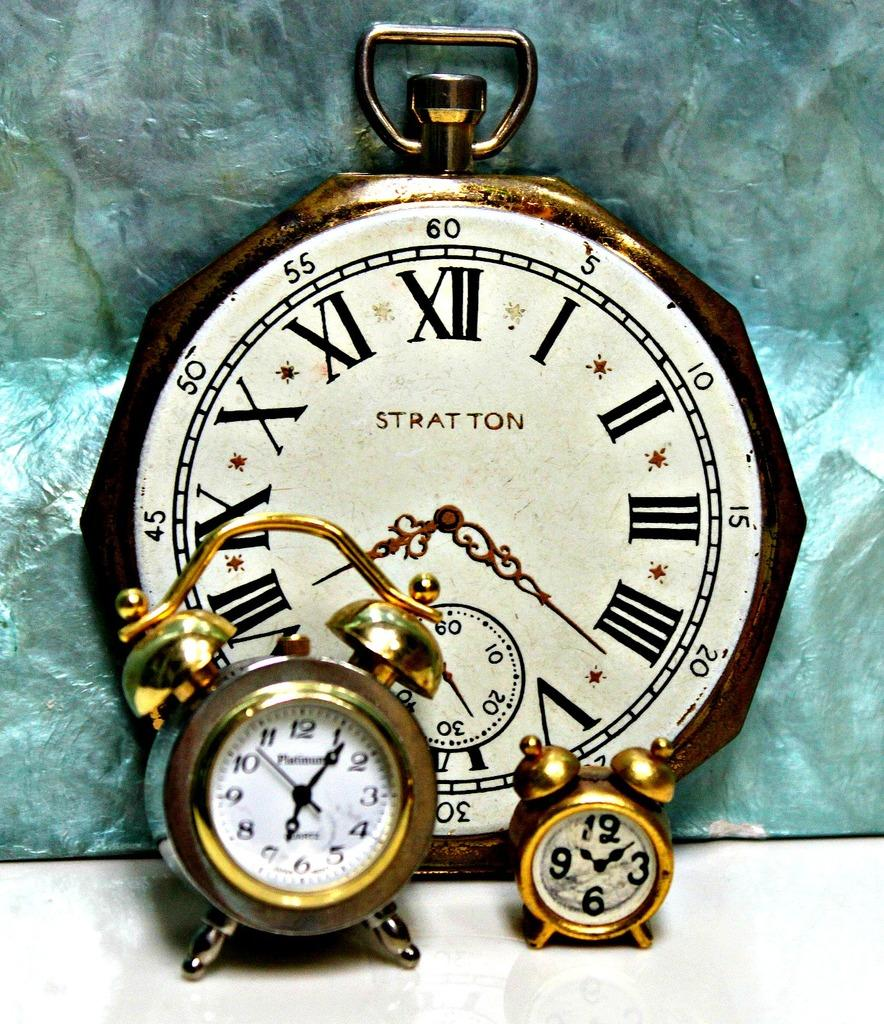What objects are present in the image? There are clocks in the picture. What color is the bottom part of the image? The bottom part of the image is white. Can you describe the background of the image? There is a blue color object in the background of the image. What type of flower is blooming in the image? There is no flower present in the image. What year is depicted in the image? The image does not depict a specific year. 